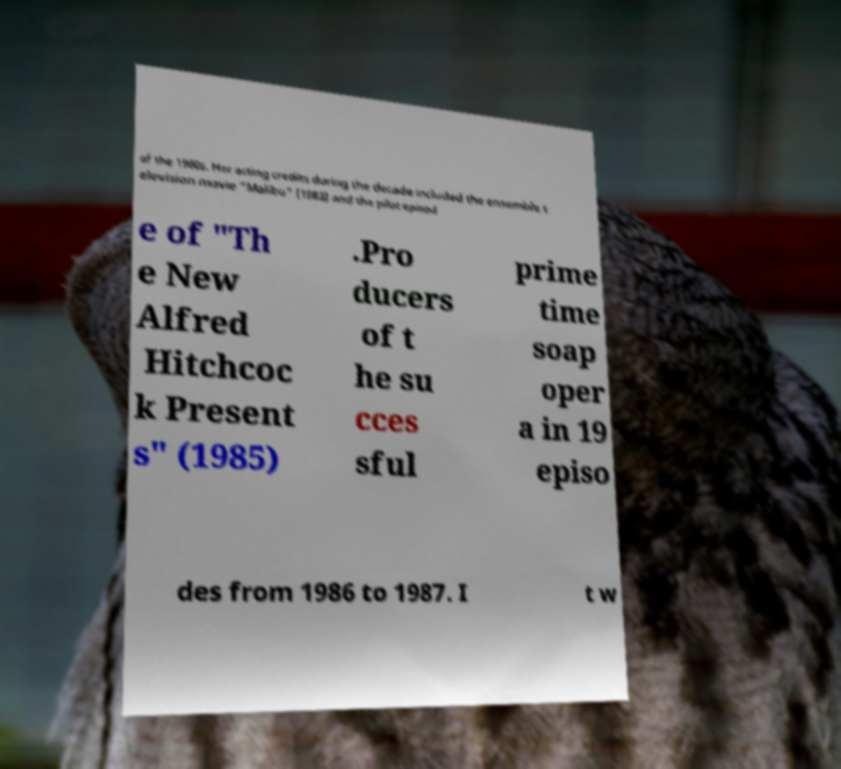Could you extract and type out the text from this image? of the 1980s. Her acting credits during the decade included the ensemble t elevision movie "Malibu" (1983) and the pilot episod e of "Th e New Alfred Hitchcoc k Present s" (1985) .Pro ducers of t he su cces sful prime time soap oper a in 19 episo des from 1986 to 1987. I t w 